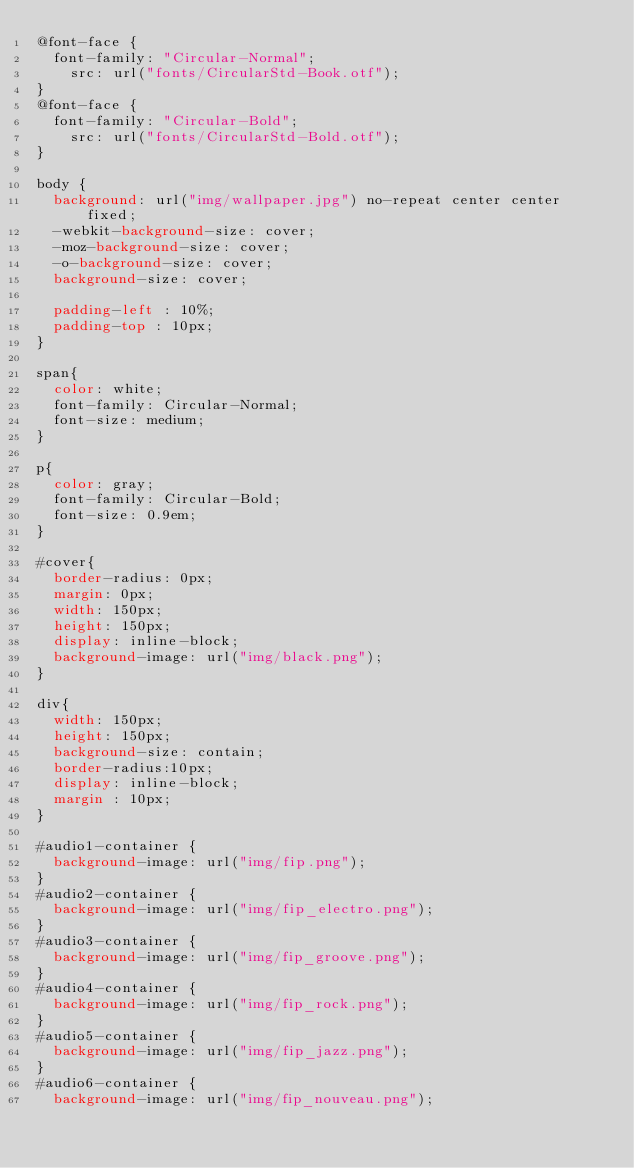Convert code to text. <code><loc_0><loc_0><loc_500><loc_500><_CSS_>@font-face {
	font-family: "Circular-Normal";
		src: url("fonts/CircularStd-Book.otf");
}
@font-face {
	font-family: "Circular-Bold";
		src: url("fonts/CircularStd-Bold.otf");
}

body {
	background: url("img/wallpaper.jpg") no-repeat center center fixed;
	-webkit-background-size: cover;
	-moz-background-size: cover;
	-o-background-size: cover;
	background-size: cover;

	padding-left : 10%;
	padding-top : 10px;
}

span{
	color: white;
	font-family: Circular-Normal;
	font-size: medium;
}

p{
	color: gray;
	font-family: Circular-Bold;
	font-size: 0.9em;
}

#cover{
	border-radius: 0px;
	margin: 0px;
	width: 150px;
	height: 150px;
	display: inline-block;
	background-image: url("img/black.png");
}

div{
	width: 150px;
	height: 150px;
	background-size: contain;
	border-radius:10px;
	display: inline-block;
	margin : 10px;
}

#audio1-container {
	background-image: url("img/fip.png");
}
#audio2-container {
	background-image: url("img/fip_electro.png");
}
#audio3-container {
	background-image: url("img/fip_groove.png");
}
#audio4-container {
	background-image: url("img/fip_rock.png");
}
#audio5-container {
	background-image: url("img/fip_jazz.png");
}
#audio6-container {
	background-image: url("img/fip_nouveau.png");</code> 